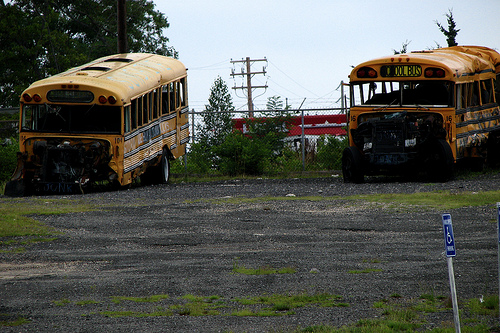What kind of vehicle is yellow? The vehicle that is yellow in color is a bus, parked on an unkempt gravel lot along with another bus. 